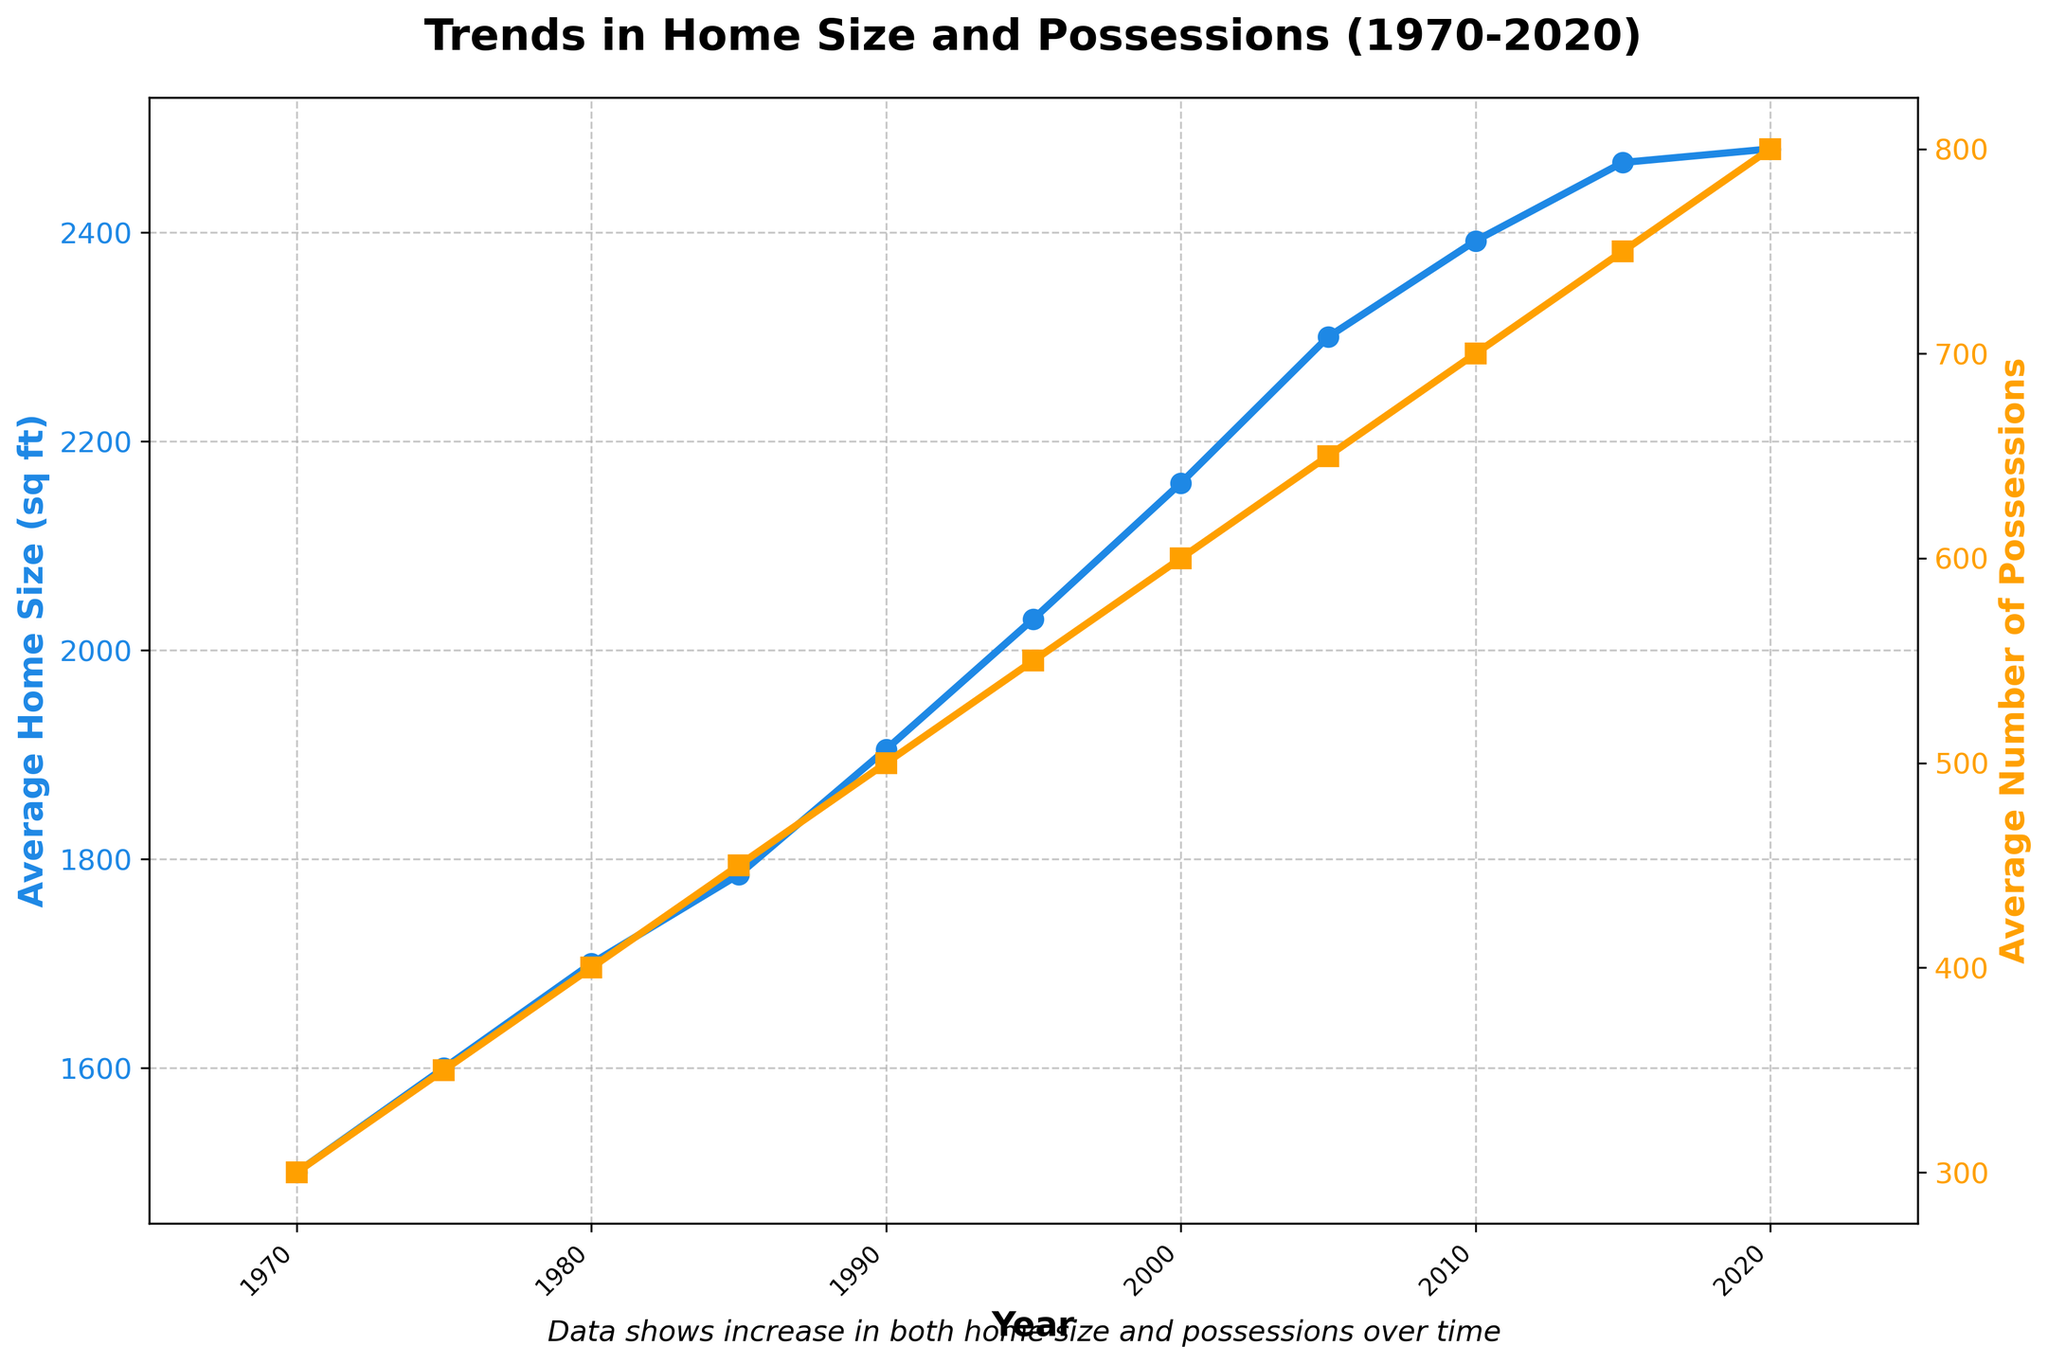What overall trend is observed in the average home size from 1970 to 2020? The average home size shows a steady increase from 1970 to 2020, growing from 1500 sq ft to 2480 sq ft, reflecting a general upward trend over the 50-year period.
Answer: Steady increase By how much did the average home size increase between 1970 and 2020? The average home size in 1970 was 1500 sq ft, and in 2020 it was 2480 sq ft. The increase is calculated as 2480 - 1500 = 980 sq ft.
Answer: 980 sq ft Which year marks the highest average number of possessions? The year 2020 marks the highest average number of possessions, with 800 possessions.
Answer: 2020 Compare the average number of possessions in 1980 and 2000. Which year had more possessions, and by how much? In 1980, the average number of possessions was 400, while in 2000 it was 600. The difference is 600 - 400 = 200 possessions. So, 2000 had more possessions by 200.
Answer: 2000, by 200 possessions What can you infer about the trend in the number of possessions compared to the trend in home sizes? Both trends show an overall increase over the 50-year period, but the number of possessions grew at a faster rate than home sizes.
Answer: Both increased, possessions grew faster How does the average home size in 2010 compare to that in 1990? In 1990, the average home size was 1905 sq ft, and in 2010 it was 2392 sq ft. The increase is 2392 - 1905 = 487 sq ft.
Answer: 487 sq ft What visual element helps differentiate the trends in home size and possessions? Different colors are used: blue for home size and orange for possessions, along with different markers (circles for home size and squares for possessions).
Answer: Colors and markers Using the figure, estimate the average home size around the year 1985. From the plot, the average home size in 1985 is approximately 1785 sq ft.
Answer: 1785 sq ft In which period did the average home size grow the fastest, and by how much? Consider two consecutive data points. The fastest growth in average home size occurred between 2000 and 2005, with an increase from 2160 sq ft to 2300 sq ft. The growth is 2300 - 2160 = 140 sq ft.
Answer: 2000-2005, by 140 sq ft Is there any year where both the average home size and the average number of possessions show significant changes? If so, which year and what are the changes? The year 2005 shows significant changes in both metrics: the average home size increased from 2160 sq ft (2000) to 2300 sq ft (2005) and the average number of possessions increased from 600 (2000) to 650 (2005).
Answer: 2005, home size increased by 140 sq ft, possessions by 50 